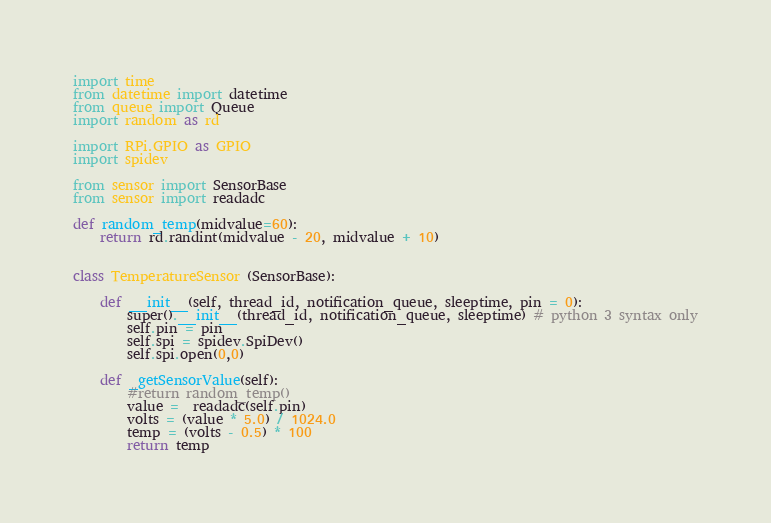Convert code to text. <code><loc_0><loc_0><loc_500><loc_500><_Python_>import time
from datetime import datetime
from queue import Queue
import random as rd

import RPi.GPIO as GPIO
import spidev

from sensor import SensorBase
from sensor import readadc

def random_temp(midvalue=60):
    return rd.randint(midvalue - 20, midvalue + 10)


class TemperatureSensor (SensorBase):

    def __init__(self, thread_id, notification_queue, sleeptime, pin = 0):
        super().__init__(thread_id, notification_queue, sleeptime) # python 3 syntax only
        self.pin = pin
        self.spi = spidev.SpiDev()
        self.spi.open(0,0)

    def _getSensorValue(self):
        #return random_temp()
        value =  readadc(self.pin)
        volts = (value * 5.0) / 1024.0
        temp = (volts - 0.5) * 100
        return temp</code> 